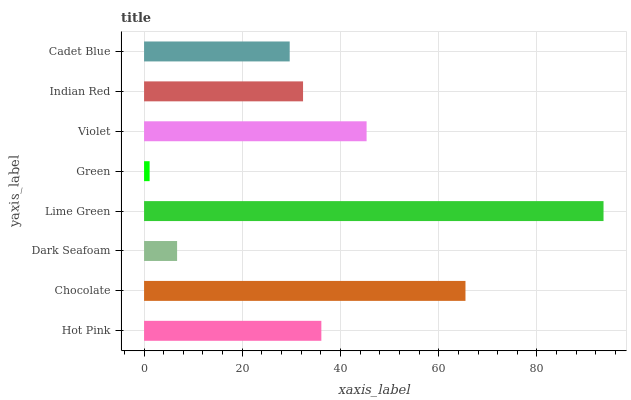Is Green the minimum?
Answer yes or no. Yes. Is Lime Green the maximum?
Answer yes or no. Yes. Is Chocolate the minimum?
Answer yes or no. No. Is Chocolate the maximum?
Answer yes or no. No. Is Chocolate greater than Hot Pink?
Answer yes or no. Yes. Is Hot Pink less than Chocolate?
Answer yes or no. Yes. Is Hot Pink greater than Chocolate?
Answer yes or no. No. Is Chocolate less than Hot Pink?
Answer yes or no. No. Is Hot Pink the high median?
Answer yes or no. Yes. Is Indian Red the low median?
Answer yes or no. Yes. Is Green the high median?
Answer yes or no. No. Is Hot Pink the low median?
Answer yes or no. No. 